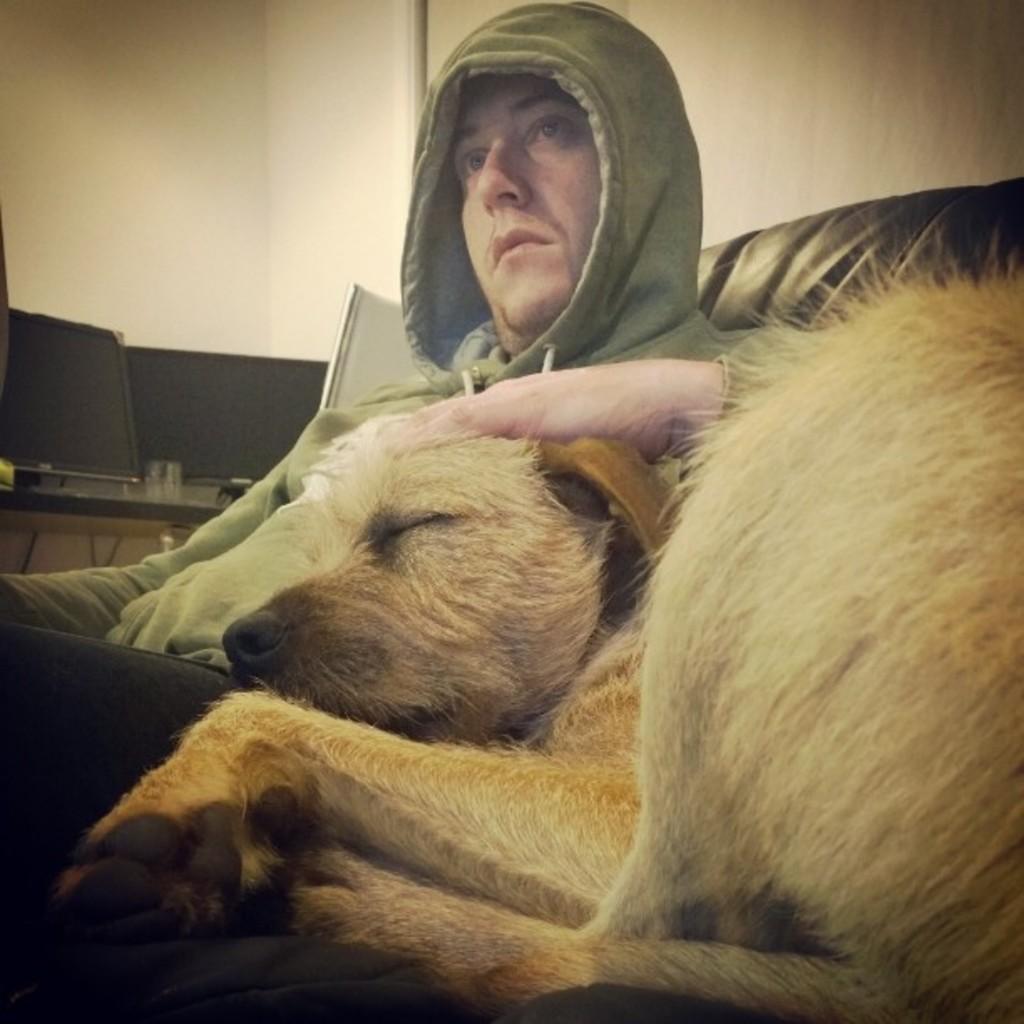How would you summarize this image in a sentence or two? In this picture we can see a man sitting on a chair, there is a dog behind him, in the background we can see a monitor and wall. 